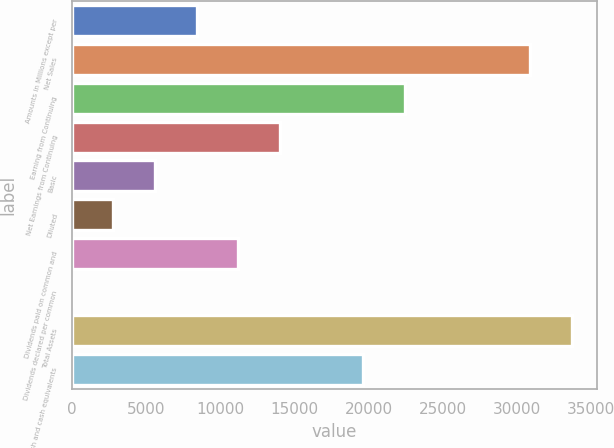Convert chart. <chart><loc_0><loc_0><loc_500><loc_500><bar_chart><fcel>Amounts in Millions except per<fcel>Net Sales<fcel>Earning from Continuing<fcel>Net Earnings from Continuing<fcel>Basic<fcel>Diluted<fcel>Dividends paid on common and<fcel>Dividends declared per common<fcel>Total Assets<fcel>Cash and cash equivalents<nl><fcel>8421.19<fcel>30874.7<fcel>22454.6<fcel>14034.6<fcel>5614.5<fcel>2807.81<fcel>11227.9<fcel>1.12<fcel>33681.4<fcel>19648<nl></chart> 